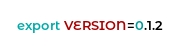Convert code to text. <code><loc_0><loc_0><loc_500><loc_500><_Bash_>export VERSION=0.1.2
</code> 